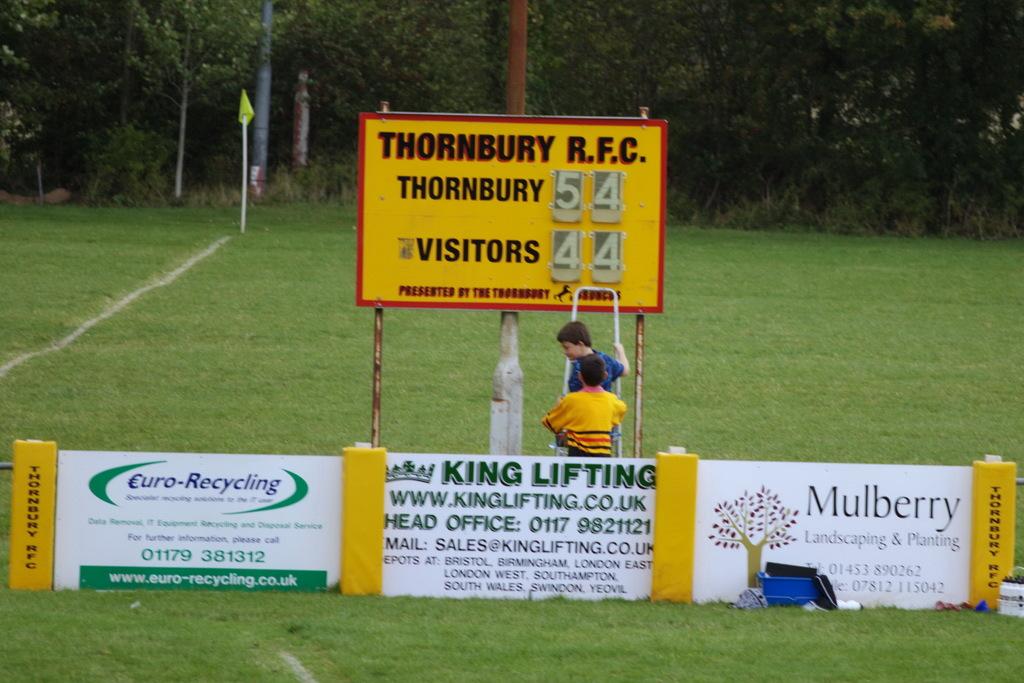What is thornburys score?
Give a very brief answer. 54. What is the number of thornbury verses visitors?
Your response must be concise. 54 to 44. 